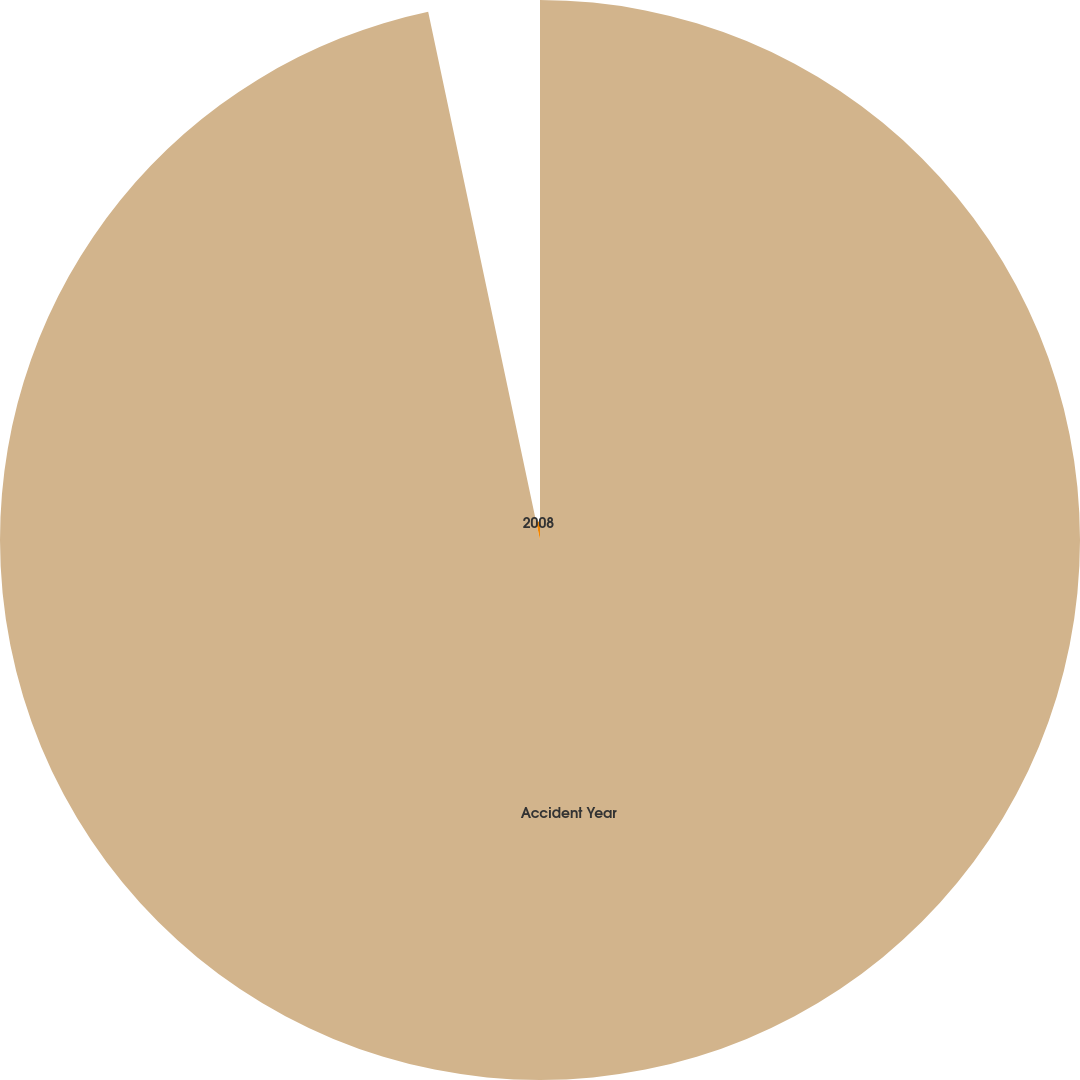Convert chart. <chart><loc_0><loc_0><loc_500><loc_500><pie_chart><fcel>Accident Year<fcel>2008<nl><fcel>96.68%<fcel>3.32%<nl></chart> 